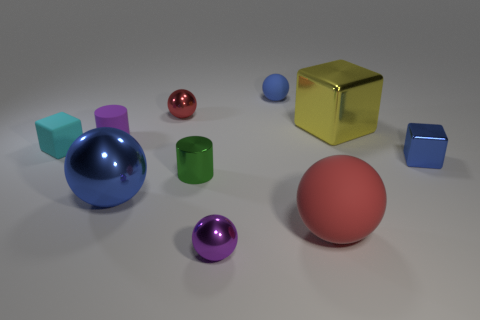Subtract all tiny purple shiny spheres. How many spheres are left? 4 Subtract all purple balls. How many balls are left? 4 Subtract all brown cylinders. Subtract all green balls. How many cylinders are left? 2 Subtract all cubes. How many objects are left? 7 Add 4 tiny cyan rubber cubes. How many tiny cyan rubber cubes are left? 5 Add 1 gray metal cubes. How many gray metal cubes exist? 1 Subtract 0 blue cylinders. How many objects are left? 10 Subtract all small brown matte things. Subtract all yellow cubes. How many objects are left? 9 